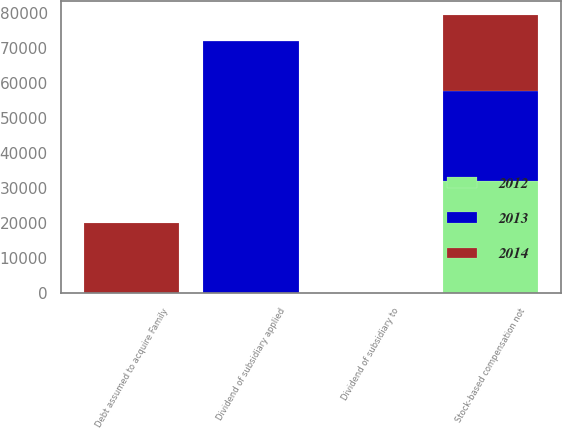Convert chart to OTSL. <chart><loc_0><loc_0><loc_500><loc_500><stacked_bar_chart><ecel><fcel>Stock-based compensation not<fcel>Debt assumed to acquire Family<fcel>Dividend of subsidiary to<fcel>Dividend of subsidiary applied<nl><fcel>2012<fcel>32203<fcel>0<fcel>0<fcel>0<nl><fcel>2013<fcel>25642<fcel>0<fcel>0<fcel>72000<nl><fcel>2014<fcel>21605<fcel>20000<fcel>0<fcel>0<nl></chart> 